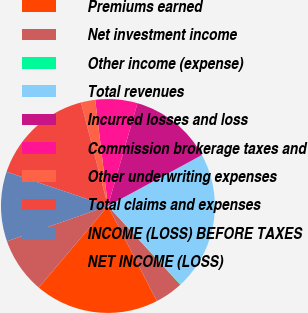Convert chart. <chart><loc_0><loc_0><loc_500><loc_500><pie_chart><fcel>Premiums earned<fcel>Net investment income<fcel>Other income (expense)<fcel>Total revenues<fcel>Incurred losses and loss<fcel>Commission brokerage taxes and<fcel>Other underwriting expenses<fcel>Total claims and expenses<fcel>INCOME (LOSS) BEFORE TAXES<fcel>NET INCOME (LOSS)<nl><fcel>18.76%<fcel>4.26%<fcel>0.07%<fcel>21.01%<fcel>12.64%<fcel>6.35%<fcel>2.16%<fcel>15.77%<fcel>10.54%<fcel>8.45%<nl></chart> 